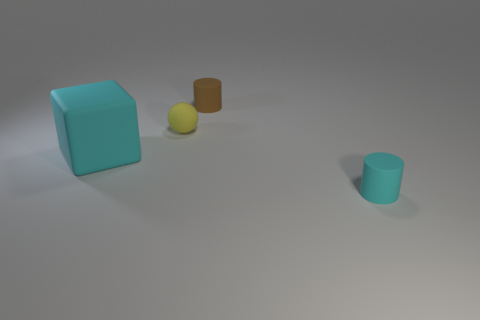There is another cylinder that is the same size as the cyan cylinder; what material is it?
Offer a very short reply. Rubber. There is a cyan thing that is behind the cyan matte thing that is on the right side of the small cylinder behind the big cyan object; what is it made of?
Provide a succinct answer. Rubber. Do the cylinder in front of the yellow matte thing and the cyan rubber block have the same size?
Provide a succinct answer. No. Are there more big matte things than tiny gray rubber cylinders?
Give a very brief answer. Yes. How many small objects are yellow shiny cubes or cyan rubber cubes?
Provide a short and direct response. 0. How many other objects are the same color as the rubber sphere?
Your response must be concise. 0. What number of other small things have the same material as the tiny brown thing?
Make the answer very short. 2. There is a rubber cylinder behind the yellow rubber sphere; does it have the same color as the small rubber sphere?
Your answer should be compact. No. What number of cyan objects are either big things or rubber cylinders?
Your answer should be very brief. 2. Is there anything else that has the same material as the large block?
Ensure brevity in your answer.  Yes. 